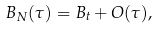Convert formula to latex. <formula><loc_0><loc_0><loc_500><loc_500>B _ { N } ( \tau ) = B _ { t } + O ( \tau ) ,</formula> 